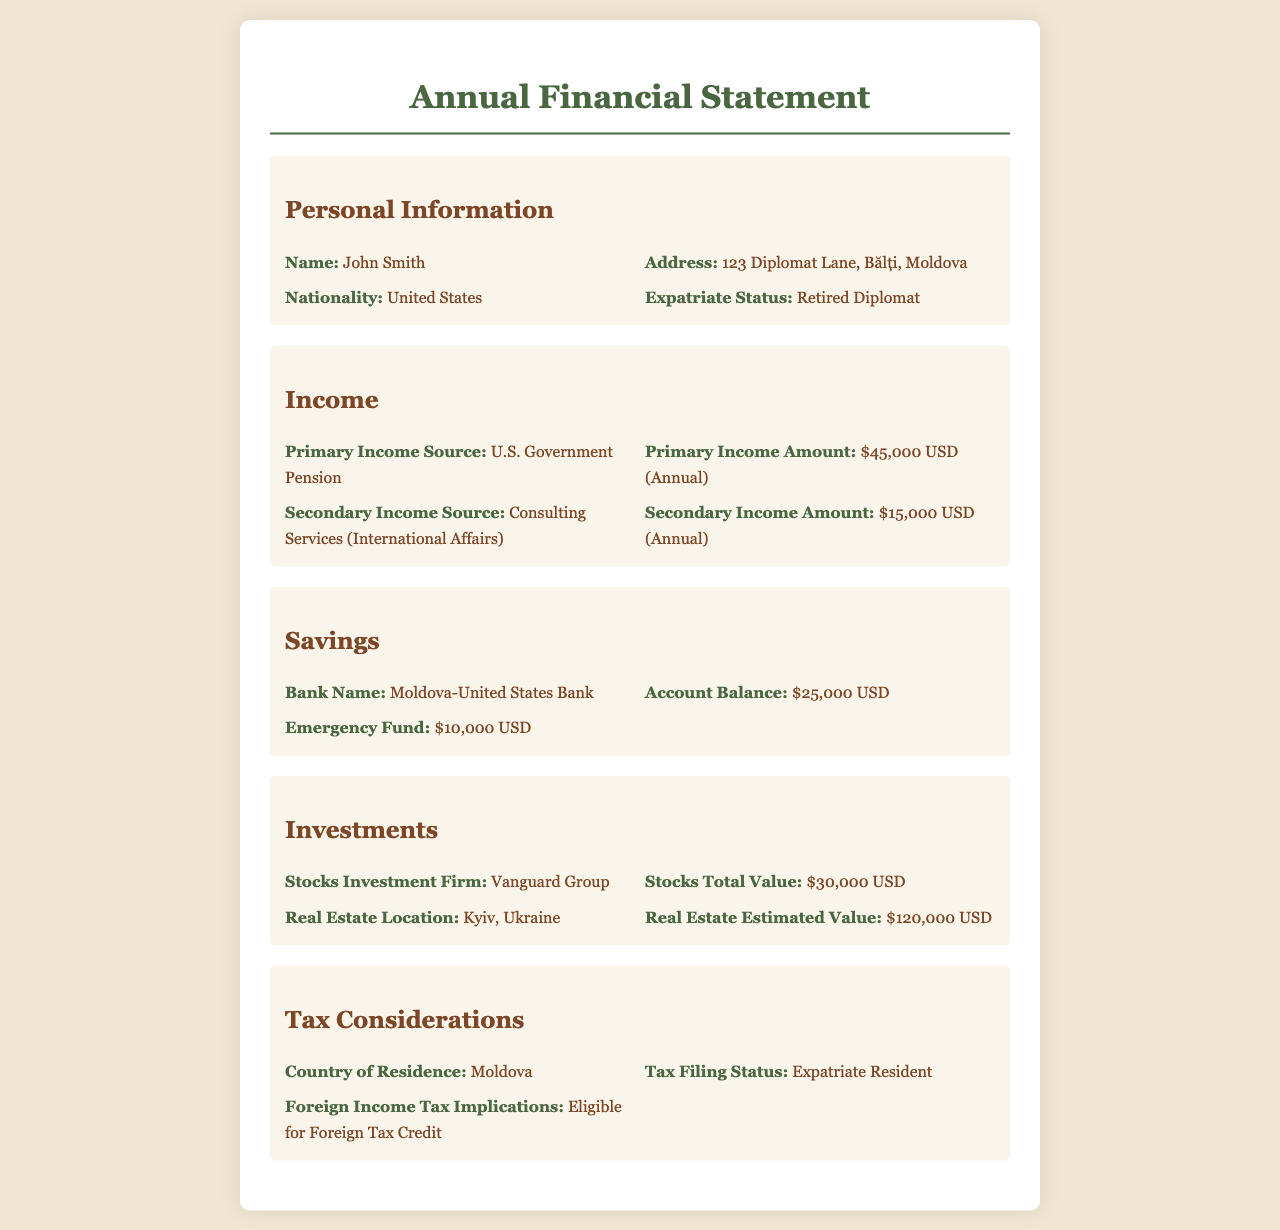What is the primary income source? The primary income source is listed under the income section of the document, which is the U.S. Government Pension.
Answer: U.S. Government Pension What is John Smith's address? The address is provided in the personal information section of the document as 123 Diplomat Lane, Bălți, Moldova.
Answer: 123 Diplomat Lane, Bălți, Moldova How much is the total value of real estate? The total value of real estate can be found in the investments section, which states $120,000 USD as the estimated value.
Answer: $120,000 USD What is the account balance at the bank? The account balance is included in the savings section, which lists it as $25,000 USD.
Answer: $25,000 USD What is the annual amount from consulting services? The annual amount from consulting services is detailed in the income section, where it states $15,000 USD.
Answer: $15,000 USD What tax filing status is mentioned? The tax filing status can be found in the tax considerations section of the document, which is noted as Expatriate Resident.
Answer: Expatriate Resident Which country is listed as the country of residence? The country of residence is specified in the tax considerations section and is Moldova.
Answer: Moldova Who is the stocks investment firm? The stocks investment firm is identified in the investments section, namely Vanguard Group.
Answer: Vanguard Group What is the amount in the emergency fund? The emergency fund amount is noted in the savings section as $10,000 USD.
Answer: $10,000 USD 